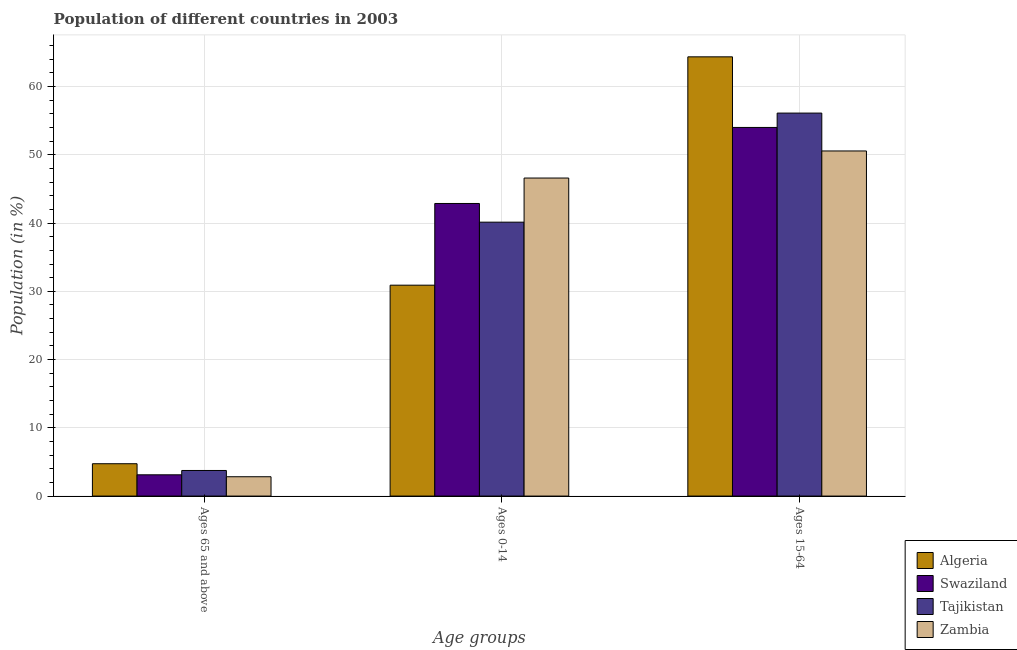How many bars are there on the 2nd tick from the left?
Your response must be concise. 4. How many bars are there on the 1st tick from the right?
Your answer should be very brief. 4. What is the label of the 1st group of bars from the left?
Ensure brevity in your answer.  Ages 65 and above. What is the percentage of population within the age-group 15-64 in Tajikistan?
Give a very brief answer. 56.12. Across all countries, what is the maximum percentage of population within the age-group 0-14?
Ensure brevity in your answer.  46.6. Across all countries, what is the minimum percentage of population within the age-group 15-64?
Offer a very short reply. 50.57. In which country was the percentage of population within the age-group 15-64 maximum?
Offer a very short reply. Algeria. In which country was the percentage of population within the age-group of 65 and above minimum?
Offer a very short reply. Zambia. What is the total percentage of population within the age-group 15-64 in the graph?
Provide a short and direct response. 225.06. What is the difference between the percentage of population within the age-group 0-14 in Swaziland and that in Algeria?
Provide a short and direct response. 11.97. What is the difference between the percentage of population within the age-group of 65 and above in Algeria and the percentage of population within the age-group 0-14 in Swaziland?
Your response must be concise. -38.13. What is the average percentage of population within the age-group 0-14 per country?
Your answer should be very brief. 40.13. What is the difference between the percentage of population within the age-group 0-14 and percentage of population within the age-group of 65 and above in Swaziland?
Provide a short and direct response. 39.76. In how many countries, is the percentage of population within the age-group 0-14 greater than 30 %?
Make the answer very short. 4. What is the ratio of the percentage of population within the age-group of 65 and above in Swaziland to that in Algeria?
Provide a short and direct response. 0.66. Is the difference between the percentage of population within the age-group 15-64 in Algeria and Tajikistan greater than the difference between the percentage of population within the age-group of 65 and above in Algeria and Tajikistan?
Your response must be concise. Yes. What is the difference between the highest and the second highest percentage of population within the age-group of 65 and above?
Provide a succinct answer. 0.99. What is the difference between the highest and the lowest percentage of population within the age-group 0-14?
Your response must be concise. 15.7. What does the 4th bar from the left in Ages 15-64 represents?
Ensure brevity in your answer.  Zambia. What does the 3rd bar from the right in Ages 0-14 represents?
Provide a succinct answer. Swaziland. Are all the bars in the graph horizontal?
Your answer should be compact. No. How many countries are there in the graph?
Keep it short and to the point. 4. What is the difference between two consecutive major ticks on the Y-axis?
Ensure brevity in your answer.  10. Are the values on the major ticks of Y-axis written in scientific E-notation?
Keep it short and to the point. No. Does the graph contain any zero values?
Ensure brevity in your answer.  No. Does the graph contain grids?
Provide a succinct answer. Yes. Where does the legend appear in the graph?
Provide a short and direct response. Bottom right. How are the legend labels stacked?
Your response must be concise. Vertical. What is the title of the graph?
Offer a terse response. Population of different countries in 2003. What is the label or title of the X-axis?
Provide a succinct answer. Age groups. What is the label or title of the Y-axis?
Ensure brevity in your answer.  Population (in %). What is the Population (in %) in Algeria in Ages 65 and above?
Keep it short and to the point. 4.74. What is the Population (in %) in Swaziland in Ages 65 and above?
Provide a succinct answer. 3.12. What is the Population (in %) in Tajikistan in Ages 65 and above?
Your answer should be very brief. 3.75. What is the Population (in %) of Zambia in Ages 65 and above?
Provide a short and direct response. 2.83. What is the Population (in %) of Algeria in Ages 0-14?
Offer a very short reply. 30.9. What is the Population (in %) of Swaziland in Ages 0-14?
Ensure brevity in your answer.  42.87. What is the Population (in %) of Tajikistan in Ages 0-14?
Make the answer very short. 40.13. What is the Population (in %) in Zambia in Ages 0-14?
Keep it short and to the point. 46.6. What is the Population (in %) in Algeria in Ages 15-64?
Give a very brief answer. 64.36. What is the Population (in %) of Swaziland in Ages 15-64?
Keep it short and to the point. 54.01. What is the Population (in %) of Tajikistan in Ages 15-64?
Your response must be concise. 56.12. What is the Population (in %) of Zambia in Ages 15-64?
Keep it short and to the point. 50.57. Across all Age groups, what is the maximum Population (in %) of Algeria?
Your answer should be compact. 64.36. Across all Age groups, what is the maximum Population (in %) in Swaziland?
Make the answer very short. 54.01. Across all Age groups, what is the maximum Population (in %) of Tajikistan?
Your answer should be very brief. 56.12. Across all Age groups, what is the maximum Population (in %) in Zambia?
Provide a short and direct response. 50.57. Across all Age groups, what is the minimum Population (in %) in Algeria?
Your answer should be very brief. 4.74. Across all Age groups, what is the minimum Population (in %) of Swaziland?
Keep it short and to the point. 3.12. Across all Age groups, what is the minimum Population (in %) in Tajikistan?
Provide a short and direct response. 3.75. Across all Age groups, what is the minimum Population (in %) of Zambia?
Give a very brief answer. 2.83. What is the total Population (in %) of Zambia in the graph?
Make the answer very short. 100. What is the difference between the Population (in %) in Algeria in Ages 65 and above and that in Ages 0-14?
Ensure brevity in your answer.  -26.16. What is the difference between the Population (in %) in Swaziland in Ages 65 and above and that in Ages 0-14?
Offer a very short reply. -39.76. What is the difference between the Population (in %) in Tajikistan in Ages 65 and above and that in Ages 0-14?
Keep it short and to the point. -36.38. What is the difference between the Population (in %) in Zambia in Ages 65 and above and that in Ages 0-14?
Your answer should be compact. -43.77. What is the difference between the Population (in %) in Algeria in Ages 65 and above and that in Ages 15-64?
Your answer should be compact. -59.62. What is the difference between the Population (in %) of Swaziland in Ages 65 and above and that in Ages 15-64?
Provide a short and direct response. -50.9. What is the difference between the Population (in %) in Tajikistan in Ages 65 and above and that in Ages 15-64?
Keep it short and to the point. -52.37. What is the difference between the Population (in %) in Zambia in Ages 65 and above and that in Ages 15-64?
Offer a very short reply. -47.74. What is the difference between the Population (in %) of Algeria in Ages 0-14 and that in Ages 15-64?
Provide a short and direct response. -33.46. What is the difference between the Population (in %) of Swaziland in Ages 0-14 and that in Ages 15-64?
Your answer should be very brief. -11.14. What is the difference between the Population (in %) in Tajikistan in Ages 0-14 and that in Ages 15-64?
Make the answer very short. -15.98. What is the difference between the Population (in %) in Zambia in Ages 0-14 and that in Ages 15-64?
Provide a short and direct response. -3.97. What is the difference between the Population (in %) in Algeria in Ages 65 and above and the Population (in %) in Swaziland in Ages 0-14?
Keep it short and to the point. -38.13. What is the difference between the Population (in %) of Algeria in Ages 65 and above and the Population (in %) of Tajikistan in Ages 0-14?
Provide a short and direct response. -35.39. What is the difference between the Population (in %) of Algeria in Ages 65 and above and the Population (in %) of Zambia in Ages 0-14?
Keep it short and to the point. -41.86. What is the difference between the Population (in %) of Swaziland in Ages 65 and above and the Population (in %) of Tajikistan in Ages 0-14?
Offer a very short reply. -37.02. What is the difference between the Population (in %) in Swaziland in Ages 65 and above and the Population (in %) in Zambia in Ages 0-14?
Provide a succinct answer. -43.48. What is the difference between the Population (in %) in Tajikistan in Ages 65 and above and the Population (in %) in Zambia in Ages 0-14?
Offer a terse response. -42.85. What is the difference between the Population (in %) of Algeria in Ages 65 and above and the Population (in %) of Swaziland in Ages 15-64?
Your answer should be very brief. -49.27. What is the difference between the Population (in %) in Algeria in Ages 65 and above and the Population (in %) in Tajikistan in Ages 15-64?
Your response must be concise. -51.38. What is the difference between the Population (in %) in Algeria in Ages 65 and above and the Population (in %) in Zambia in Ages 15-64?
Offer a terse response. -45.83. What is the difference between the Population (in %) of Swaziland in Ages 65 and above and the Population (in %) of Tajikistan in Ages 15-64?
Your answer should be compact. -53. What is the difference between the Population (in %) of Swaziland in Ages 65 and above and the Population (in %) of Zambia in Ages 15-64?
Provide a succinct answer. -47.45. What is the difference between the Population (in %) of Tajikistan in Ages 65 and above and the Population (in %) of Zambia in Ages 15-64?
Provide a short and direct response. -46.82. What is the difference between the Population (in %) in Algeria in Ages 0-14 and the Population (in %) in Swaziland in Ages 15-64?
Offer a terse response. -23.11. What is the difference between the Population (in %) of Algeria in Ages 0-14 and the Population (in %) of Tajikistan in Ages 15-64?
Offer a very short reply. -25.22. What is the difference between the Population (in %) of Algeria in Ages 0-14 and the Population (in %) of Zambia in Ages 15-64?
Make the answer very short. -19.67. What is the difference between the Population (in %) of Swaziland in Ages 0-14 and the Population (in %) of Tajikistan in Ages 15-64?
Give a very brief answer. -13.25. What is the difference between the Population (in %) of Swaziland in Ages 0-14 and the Population (in %) of Zambia in Ages 15-64?
Provide a succinct answer. -7.7. What is the difference between the Population (in %) of Tajikistan in Ages 0-14 and the Population (in %) of Zambia in Ages 15-64?
Keep it short and to the point. -10.43. What is the average Population (in %) in Algeria per Age groups?
Your answer should be compact. 33.33. What is the average Population (in %) in Swaziland per Age groups?
Provide a succinct answer. 33.33. What is the average Population (in %) in Tajikistan per Age groups?
Keep it short and to the point. 33.33. What is the average Population (in %) of Zambia per Age groups?
Make the answer very short. 33.33. What is the difference between the Population (in %) in Algeria and Population (in %) in Swaziland in Ages 65 and above?
Your answer should be compact. 1.62. What is the difference between the Population (in %) in Algeria and Population (in %) in Zambia in Ages 65 and above?
Offer a very short reply. 1.91. What is the difference between the Population (in %) in Swaziland and Population (in %) in Tajikistan in Ages 65 and above?
Provide a succinct answer. -0.63. What is the difference between the Population (in %) of Swaziland and Population (in %) of Zambia in Ages 65 and above?
Keep it short and to the point. 0.28. What is the difference between the Population (in %) in Tajikistan and Population (in %) in Zambia in Ages 65 and above?
Your response must be concise. 0.92. What is the difference between the Population (in %) in Algeria and Population (in %) in Swaziland in Ages 0-14?
Your response must be concise. -11.97. What is the difference between the Population (in %) of Algeria and Population (in %) of Tajikistan in Ages 0-14?
Make the answer very short. -9.23. What is the difference between the Population (in %) in Algeria and Population (in %) in Zambia in Ages 0-14?
Provide a succinct answer. -15.7. What is the difference between the Population (in %) of Swaziland and Population (in %) of Tajikistan in Ages 0-14?
Offer a very short reply. 2.74. What is the difference between the Population (in %) of Swaziland and Population (in %) of Zambia in Ages 0-14?
Offer a terse response. -3.73. What is the difference between the Population (in %) in Tajikistan and Population (in %) in Zambia in Ages 0-14?
Keep it short and to the point. -6.47. What is the difference between the Population (in %) in Algeria and Population (in %) in Swaziland in Ages 15-64?
Your response must be concise. 10.35. What is the difference between the Population (in %) of Algeria and Population (in %) of Tajikistan in Ages 15-64?
Keep it short and to the point. 8.24. What is the difference between the Population (in %) in Algeria and Population (in %) in Zambia in Ages 15-64?
Your answer should be compact. 13.79. What is the difference between the Population (in %) of Swaziland and Population (in %) of Tajikistan in Ages 15-64?
Ensure brevity in your answer.  -2.11. What is the difference between the Population (in %) of Swaziland and Population (in %) of Zambia in Ages 15-64?
Your response must be concise. 3.44. What is the difference between the Population (in %) in Tajikistan and Population (in %) in Zambia in Ages 15-64?
Ensure brevity in your answer.  5.55. What is the ratio of the Population (in %) in Algeria in Ages 65 and above to that in Ages 0-14?
Your response must be concise. 0.15. What is the ratio of the Population (in %) in Swaziland in Ages 65 and above to that in Ages 0-14?
Provide a short and direct response. 0.07. What is the ratio of the Population (in %) in Tajikistan in Ages 65 and above to that in Ages 0-14?
Make the answer very short. 0.09. What is the ratio of the Population (in %) of Zambia in Ages 65 and above to that in Ages 0-14?
Provide a succinct answer. 0.06. What is the ratio of the Population (in %) of Algeria in Ages 65 and above to that in Ages 15-64?
Offer a terse response. 0.07. What is the ratio of the Population (in %) in Swaziland in Ages 65 and above to that in Ages 15-64?
Ensure brevity in your answer.  0.06. What is the ratio of the Population (in %) in Tajikistan in Ages 65 and above to that in Ages 15-64?
Your answer should be compact. 0.07. What is the ratio of the Population (in %) in Zambia in Ages 65 and above to that in Ages 15-64?
Provide a short and direct response. 0.06. What is the ratio of the Population (in %) in Algeria in Ages 0-14 to that in Ages 15-64?
Your answer should be very brief. 0.48. What is the ratio of the Population (in %) in Swaziland in Ages 0-14 to that in Ages 15-64?
Offer a very short reply. 0.79. What is the ratio of the Population (in %) of Tajikistan in Ages 0-14 to that in Ages 15-64?
Your response must be concise. 0.72. What is the ratio of the Population (in %) in Zambia in Ages 0-14 to that in Ages 15-64?
Offer a terse response. 0.92. What is the difference between the highest and the second highest Population (in %) of Algeria?
Give a very brief answer. 33.46. What is the difference between the highest and the second highest Population (in %) of Swaziland?
Your answer should be very brief. 11.14. What is the difference between the highest and the second highest Population (in %) in Tajikistan?
Your answer should be very brief. 15.98. What is the difference between the highest and the second highest Population (in %) in Zambia?
Your answer should be compact. 3.97. What is the difference between the highest and the lowest Population (in %) of Algeria?
Keep it short and to the point. 59.62. What is the difference between the highest and the lowest Population (in %) of Swaziland?
Offer a terse response. 50.9. What is the difference between the highest and the lowest Population (in %) in Tajikistan?
Make the answer very short. 52.37. What is the difference between the highest and the lowest Population (in %) in Zambia?
Your response must be concise. 47.74. 